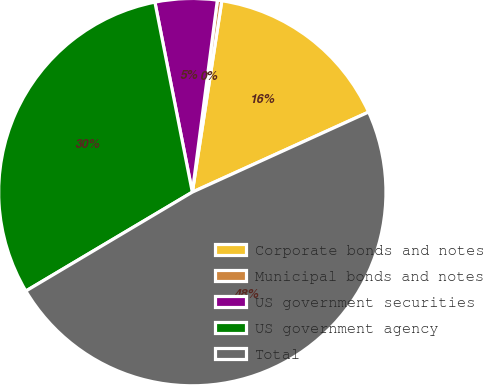Convert chart to OTSL. <chart><loc_0><loc_0><loc_500><loc_500><pie_chart><fcel>Corporate bonds and notes<fcel>Municipal bonds and notes<fcel>US government securities<fcel>US government agency<fcel>Total<nl><fcel>15.78%<fcel>0.37%<fcel>5.16%<fcel>30.44%<fcel>48.26%<nl></chart> 